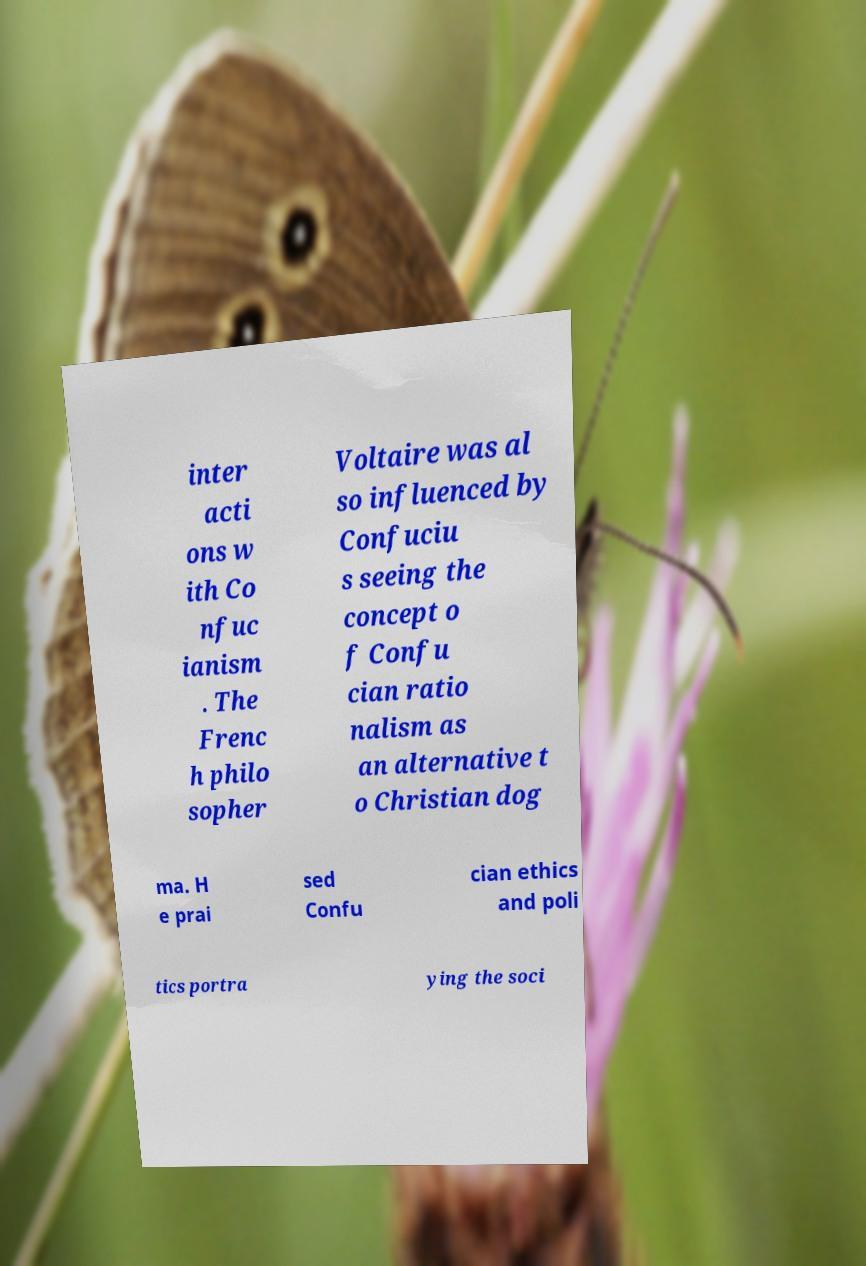For documentation purposes, I need the text within this image transcribed. Could you provide that? inter acti ons w ith Co nfuc ianism . The Frenc h philo sopher Voltaire was al so influenced by Confuciu s seeing the concept o f Confu cian ratio nalism as an alternative t o Christian dog ma. H e prai sed Confu cian ethics and poli tics portra ying the soci 